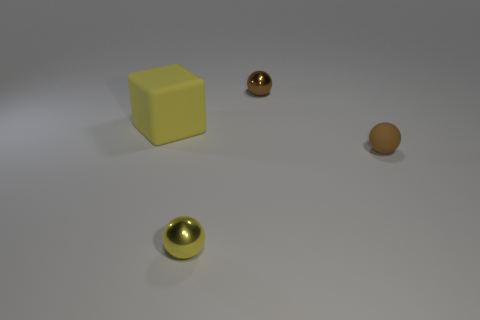Is there anything else that is the same size as the yellow matte object?
Give a very brief answer. No. Are the large yellow cube and the small thing that is in front of the tiny rubber ball made of the same material?
Your answer should be compact. No. Are there fewer yellow matte things behind the small yellow shiny ball than tiny shiny balls?
Offer a terse response. Yes. What color is the matte object that is on the left side of the brown rubber object?
Your response must be concise. Yellow. The yellow rubber object has what shape?
Make the answer very short. Cube. Is there a large rubber object to the left of the metal ball behind the big yellow matte thing behind the brown rubber object?
Provide a short and direct response. Yes. What is the color of the metal thing that is behind the small thing in front of the tiny brown object that is right of the tiny brown metallic thing?
Ensure brevity in your answer.  Brown. There is a small yellow thing that is the same shape as the brown rubber object; what is it made of?
Offer a very short reply. Metal. What size is the shiny thing that is on the left side of the small sphere behind the big matte cube?
Your response must be concise. Small. What is the small ball behind the big rubber cube made of?
Ensure brevity in your answer.  Metal. 